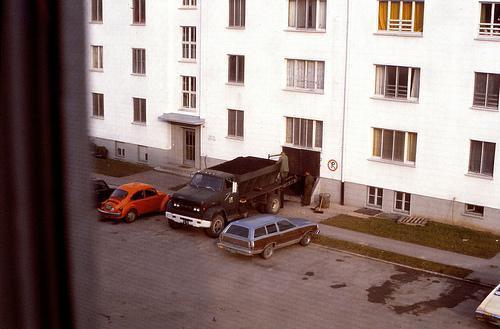How many people are visible?
Give a very brief answer. 1. 